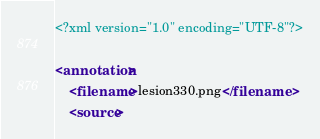Convert code to text. <code><loc_0><loc_0><loc_500><loc_500><_XML_><?xml version="1.0" encoding="UTF-8"?>

<annotation>
	<filename>lesion330.png</filename>
	<source></code> 